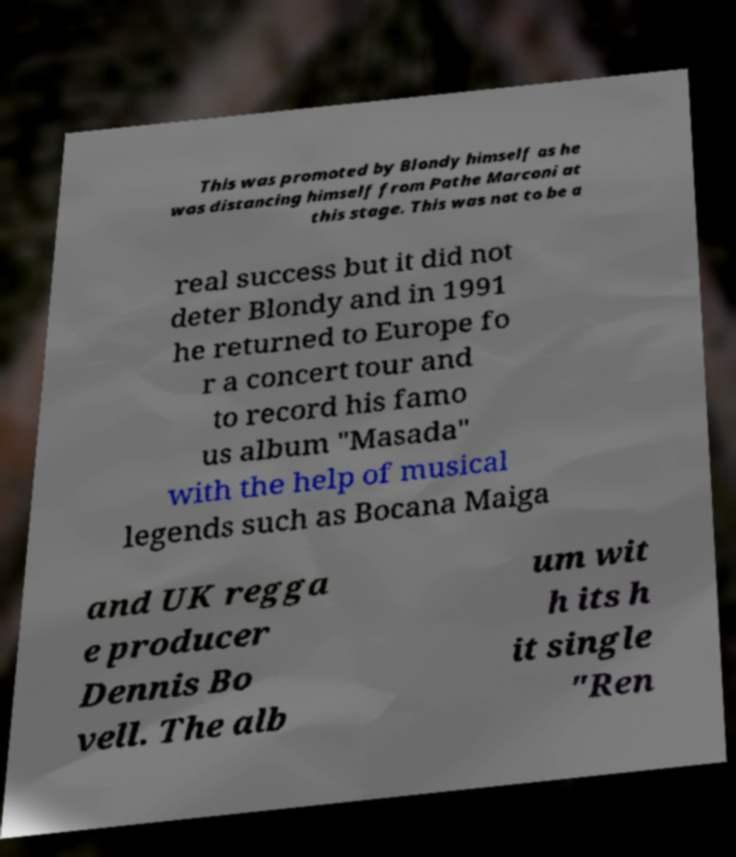What messages or text are displayed in this image? I need them in a readable, typed format. This was promoted by Blondy himself as he was distancing himself from Pathe Marconi at this stage. This was not to be a real success but it did not deter Blondy and in 1991 he returned to Europe fo r a concert tour and to record his famo us album "Masada" with the help of musical legends such as Bocana Maiga and UK regga e producer Dennis Bo vell. The alb um wit h its h it single "Ren 